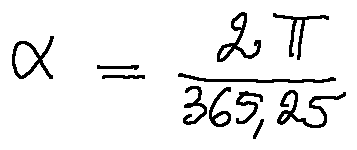<formula> <loc_0><loc_0><loc_500><loc_500>\alpha = \frac { 2 \pi } { 3 6 5 , 2 5 }</formula> 